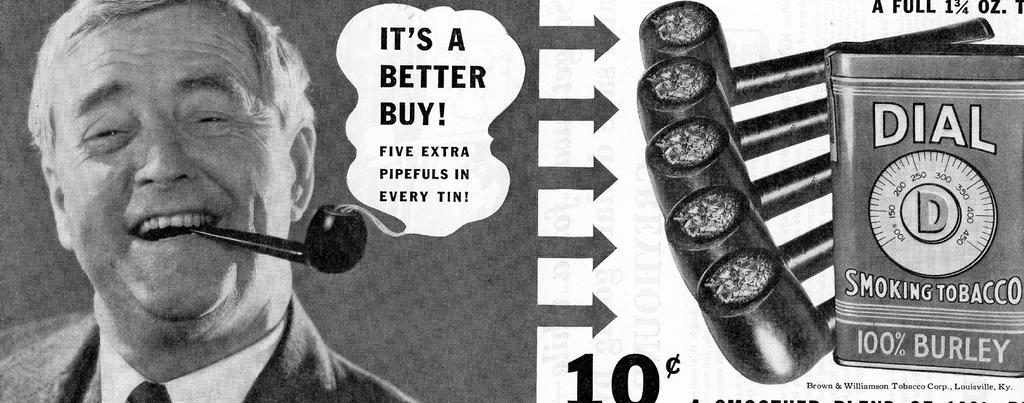Describe this image in one or two sentences. In this image I can see the person is holding the cigar pipe. I can see few cigar pipes, few object and something is written on the image. The image is in black and white. 